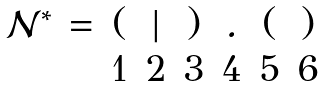<formula> <loc_0><loc_0><loc_500><loc_500>\begin{matrix} \mathcal { N } ^ { \ast } & = & ( & | & ) & . & ( & ) \\ & & 1 & 2 & 3 & 4 & 5 & 6 \end{matrix}</formula> 